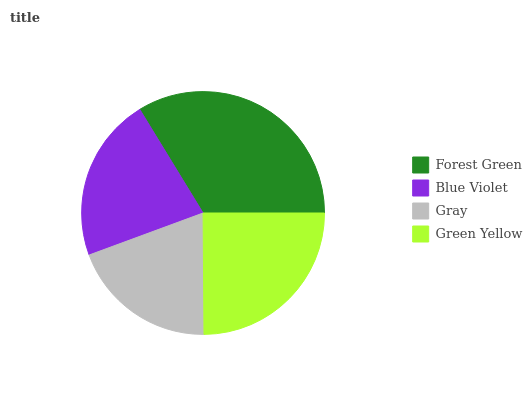Is Gray the minimum?
Answer yes or no. Yes. Is Forest Green the maximum?
Answer yes or no. Yes. Is Blue Violet the minimum?
Answer yes or no. No. Is Blue Violet the maximum?
Answer yes or no. No. Is Forest Green greater than Blue Violet?
Answer yes or no. Yes. Is Blue Violet less than Forest Green?
Answer yes or no. Yes. Is Blue Violet greater than Forest Green?
Answer yes or no. No. Is Forest Green less than Blue Violet?
Answer yes or no. No. Is Green Yellow the high median?
Answer yes or no. Yes. Is Blue Violet the low median?
Answer yes or no. Yes. Is Gray the high median?
Answer yes or no. No. Is Gray the low median?
Answer yes or no. No. 